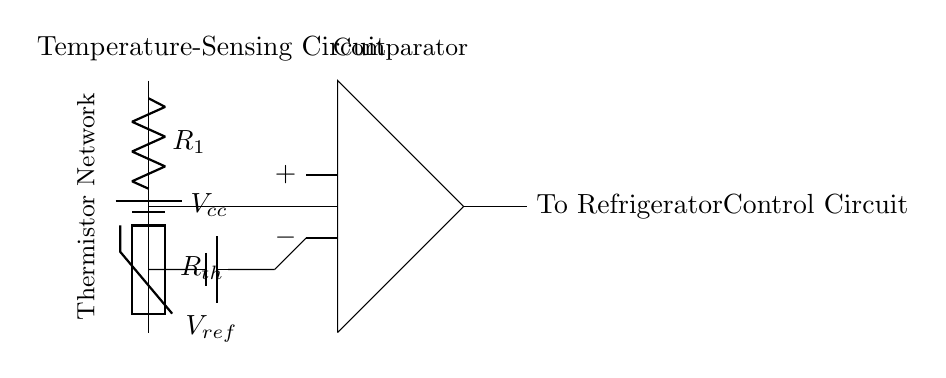What is the power supply voltage used in this circuit? The power supply voltage is denoted as Vcc, which is indicated by the battery symbol at the top left corner of the circuit. The circuit does not provide a specific numerical value for Vcc, thus the answer remains the voltage label itself.
Answer: Vcc What type of sensing element is used in this circuit? The circuit employs a thermistor as the sensing element, marked distinctly by its symbol that typically resembles a resistor with a temperature dependency indication.
Answer: Thermistor How many resistors are present in this circuit? The circuit contains two resistors: one labeled as R1 and the other represented by the thermistor (Rth), which is a type of resistor used specifically for temperature sensing.
Answer: Two What does the operational amplifier in the circuit do? The operational amplifier, denoted in the circuit, acts as a comparator, comparing the voltage from the thermistor voltage divider to the reference voltage (Vref) to determine if the conditions for the refrigerator's control system are met.
Answer: Comparator What is the role of the reference voltage in this circuit? The reference voltage, labeled as Vref, provides a stable voltage level against which the output from the thermistor is compared. It is essential for the comparator to function correctly and decide when to activate or deactivate the cooling system of the refrigerator based on temperature readings.
Answer: Stable reference for comparison What is the output of this circuit connected to? The output of the circuit is connected to the refrigerator control circuit, as indicated by the label on the right side of the output line in the circuit. This output will inform the control circuit when to activate the refrigeration process based on temperature readings.
Answer: Refrigerator control circuit 